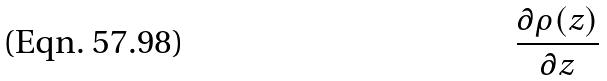Convert formula to latex. <formula><loc_0><loc_0><loc_500><loc_500>\frac { \partial \rho ( z ) } { \partial z }</formula> 